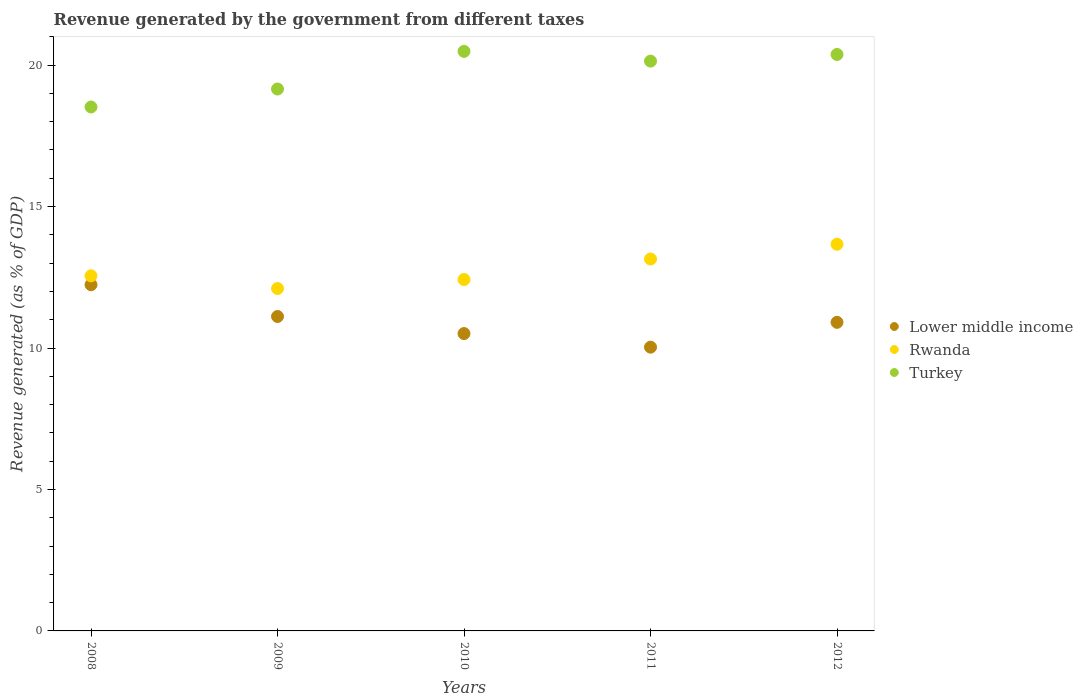How many different coloured dotlines are there?
Your answer should be compact. 3. Is the number of dotlines equal to the number of legend labels?
Offer a terse response. Yes. What is the revenue generated by the government in Rwanda in 2012?
Keep it short and to the point. 13.67. Across all years, what is the maximum revenue generated by the government in Rwanda?
Make the answer very short. 13.67. Across all years, what is the minimum revenue generated by the government in Lower middle income?
Provide a short and direct response. 10.03. What is the total revenue generated by the government in Rwanda in the graph?
Your response must be concise. 63.89. What is the difference between the revenue generated by the government in Rwanda in 2009 and that in 2010?
Your answer should be very brief. -0.32. What is the difference between the revenue generated by the government in Lower middle income in 2011 and the revenue generated by the government in Rwanda in 2009?
Give a very brief answer. -2.07. What is the average revenue generated by the government in Lower middle income per year?
Offer a very short reply. 10.96. In the year 2008, what is the difference between the revenue generated by the government in Turkey and revenue generated by the government in Rwanda?
Give a very brief answer. 5.97. What is the ratio of the revenue generated by the government in Lower middle income in 2010 to that in 2012?
Your answer should be compact. 0.96. Is the revenue generated by the government in Turkey in 2008 less than that in 2009?
Provide a succinct answer. Yes. What is the difference between the highest and the second highest revenue generated by the government in Rwanda?
Keep it short and to the point. 0.52. What is the difference between the highest and the lowest revenue generated by the government in Turkey?
Offer a very short reply. 1.97. Is the sum of the revenue generated by the government in Rwanda in 2008 and 2011 greater than the maximum revenue generated by the government in Lower middle income across all years?
Your answer should be compact. Yes. Is it the case that in every year, the sum of the revenue generated by the government in Rwanda and revenue generated by the government in Lower middle income  is greater than the revenue generated by the government in Turkey?
Give a very brief answer. Yes. Does the revenue generated by the government in Lower middle income monotonically increase over the years?
Keep it short and to the point. No. Is the revenue generated by the government in Rwanda strictly less than the revenue generated by the government in Turkey over the years?
Provide a succinct answer. Yes. How many years are there in the graph?
Make the answer very short. 5. What is the difference between two consecutive major ticks on the Y-axis?
Your response must be concise. 5. Does the graph contain any zero values?
Make the answer very short. No. Does the graph contain grids?
Make the answer very short. No. Where does the legend appear in the graph?
Offer a very short reply. Center right. How many legend labels are there?
Provide a succinct answer. 3. How are the legend labels stacked?
Your response must be concise. Vertical. What is the title of the graph?
Your response must be concise. Revenue generated by the government from different taxes. What is the label or title of the Y-axis?
Your response must be concise. Revenue generated (as % of GDP). What is the Revenue generated (as % of GDP) of Lower middle income in 2008?
Offer a very short reply. 12.24. What is the Revenue generated (as % of GDP) of Rwanda in 2008?
Make the answer very short. 12.55. What is the Revenue generated (as % of GDP) of Turkey in 2008?
Ensure brevity in your answer.  18.52. What is the Revenue generated (as % of GDP) of Lower middle income in 2009?
Make the answer very short. 11.11. What is the Revenue generated (as % of GDP) of Rwanda in 2009?
Make the answer very short. 12.1. What is the Revenue generated (as % of GDP) in Turkey in 2009?
Your answer should be compact. 19.16. What is the Revenue generated (as % of GDP) in Lower middle income in 2010?
Your answer should be compact. 10.51. What is the Revenue generated (as % of GDP) in Rwanda in 2010?
Your answer should be very brief. 12.42. What is the Revenue generated (as % of GDP) of Turkey in 2010?
Ensure brevity in your answer.  20.49. What is the Revenue generated (as % of GDP) in Lower middle income in 2011?
Your response must be concise. 10.03. What is the Revenue generated (as % of GDP) of Rwanda in 2011?
Your answer should be very brief. 13.15. What is the Revenue generated (as % of GDP) of Turkey in 2011?
Keep it short and to the point. 20.14. What is the Revenue generated (as % of GDP) of Lower middle income in 2012?
Your answer should be compact. 10.91. What is the Revenue generated (as % of GDP) of Rwanda in 2012?
Ensure brevity in your answer.  13.67. What is the Revenue generated (as % of GDP) of Turkey in 2012?
Make the answer very short. 20.38. Across all years, what is the maximum Revenue generated (as % of GDP) in Lower middle income?
Your answer should be compact. 12.24. Across all years, what is the maximum Revenue generated (as % of GDP) of Rwanda?
Provide a short and direct response. 13.67. Across all years, what is the maximum Revenue generated (as % of GDP) in Turkey?
Provide a short and direct response. 20.49. Across all years, what is the minimum Revenue generated (as % of GDP) in Lower middle income?
Your response must be concise. 10.03. Across all years, what is the minimum Revenue generated (as % of GDP) of Rwanda?
Ensure brevity in your answer.  12.1. Across all years, what is the minimum Revenue generated (as % of GDP) in Turkey?
Your answer should be compact. 18.52. What is the total Revenue generated (as % of GDP) of Lower middle income in the graph?
Offer a terse response. 54.8. What is the total Revenue generated (as % of GDP) in Rwanda in the graph?
Your response must be concise. 63.89. What is the total Revenue generated (as % of GDP) in Turkey in the graph?
Ensure brevity in your answer.  98.68. What is the difference between the Revenue generated (as % of GDP) in Lower middle income in 2008 and that in 2009?
Provide a short and direct response. 1.12. What is the difference between the Revenue generated (as % of GDP) in Rwanda in 2008 and that in 2009?
Offer a very short reply. 0.45. What is the difference between the Revenue generated (as % of GDP) of Turkey in 2008 and that in 2009?
Make the answer very short. -0.64. What is the difference between the Revenue generated (as % of GDP) in Lower middle income in 2008 and that in 2010?
Keep it short and to the point. 1.73. What is the difference between the Revenue generated (as % of GDP) in Rwanda in 2008 and that in 2010?
Give a very brief answer. 0.13. What is the difference between the Revenue generated (as % of GDP) in Turkey in 2008 and that in 2010?
Make the answer very short. -1.97. What is the difference between the Revenue generated (as % of GDP) of Lower middle income in 2008 and that in 2011?
Ensure brevity in your answer.  2.21. What is the difference between the Revenue generated (as % of GDP) of Rwanda in 2008 and that in 2011?
Keep it short and to the point. -0.59. What is the difference between the Revenue generated (as % of GDP) of Turkey in 2008 and that in 2011?
Provide a short and direct response. -1.62. What is the difference between the Revenue generated (as % of GDP) in Lower middle income in 2008 and that in 2012?
Offer a terse response. 1.33. What is the difference between the Revenue generated (as % of GDP) of Rwanda in 2008 and that in 2012?
Provide a succinct answer. -1.12. What is the difference between the Revenue generated (as % of GDP) of Turkey in 2008 and that in 2012?
Provide a succinct answer. -1.86. What is the difference between the Revenue generated (as % of GDP) of Lower middle income in 2009 and that in 2010?
Provide a succinct answer. 0.6. What is the difference between the Revenue generated (as % of GDP) of Rwanda in 2009 and that in 2010?
Provide a succinct answer. -0.32. What is the difference between the Revenue generated (as % of GDP) in Turkey in 2009 and that in 2010?
Offer a terse response. -1.33. What is the difference between the Revenue generated (as % of GDP) in Lower middle income in 2009 and that in 2011?
Provide a succinct answer. 1.08. What is the difference between the Revenue generated (as % of GDP) of Rwanda in 2009 and that in 2011?
Your answer should be very brief. -1.04. What is the difference between the Revenue generated (as % of GDP) of Turkey in 2009 and that in 2011?
Give a very brief answer. -0.99. What is the difference between the Revenue generated (as % of GDP) in Lower middle income in 2009 and that in 2012?
Offer a very short reply. 0.21. What is the difference between the Revenue generated (as % of GDP) in Rwanda in 2009 and that in 2012?
Provide a short and direct response. -1.56. What is the difference between the Revenue generated (as % of GDP) in Turkey in 2009 and that in 2012?
Make the answer very short. -1.22. What is the difference between the Revenue generated (as % of GDP) of Lower middle income in 2010 and that in 2011?
Ensure brevity in your answer.  0.48. What is the difference between the Revenue generated (as % of GDP) of Rwanda in 2010 and that in 2011?
Your response must be concise. -0.72. What is the difference between the Revenue generated (as % of GDP) in Turkey in 2010 and that in 2011?
Give a very brief answer. 0.34. What is the difference between the Revenue generated (as % of GDP) in Lower middle income in 2010 and that in 2012?
Ensure brevity in your answer.  -0.4. What is the difference between the Revenue generated (as % of GDP) in Rwanda in 2010 and that in 2012?
Give a very brief answer. -1.25. What is the difference between the Revenue generated (as % of GDP) of Turkey in 2010 and that in 2012?
Give a very brief answer. 0.11. What is the difference between the Revenue generated (as % of GDP) in Lower middle income in 2011 and that in 2012?
Your response must be concise. -0.88. What is the difference between the Revenue generated (as % of GDP) of Rwanda in 2011 and that in 2012?
Make the answer very short. -0.52. What is the difference between the Revenue generated (as % of GDP) in Turkey in 2011 and that in 2012?
Give a very brief answer. -0.24. What is the difference between the Revenue generated (as % of GDP) in Lower middle income in 2008 and the Revenue generated (as % of GDP) in Rwanda in 2009?
Provide a succinct answer. 0.13. What is the difference between the Revenue generated (as % of GDP) of Lower middle income in 2008 and the Revenue generated (as % of GDP) of Turkey in 2009?
Make the answer very short. -6.92. What is the difference between the Revenue generated (as % of GDP) of Rwanda in 2008 and the Revenue generated (as % of GDP) of Turkey in 2009?
Your answer should be very brief. -6.6. What is the difference between the Revenue generated (as % of GDP) of Lower middle income in 2008 and the Revenue generated (as % of GDP) of Rwanda in 2010?
Your response must be concise. -0.18. What is the difference between the Revenue generated (as % of GDP) of Lower middle income in 2008 and the Revenue generated (as % of GDP) of Turkey in 2010?
Your answer should be very brief. -8.25. What is the difference between the Revenue generated (as % of GDP) in Rwanda in 2008 and the Revenue generated (as % of GDP) in Turkey in 2010?
Give a very brief answer. -7.93. What is the difference between the Revenue generated (as % of GDP) of Lower middle income in 2008 and the Revenue generated (as % of GDP) of Rwanda in 2011?
Provide a short and direct response. -0.91. What is the difference between the Revenue generated (as % of GDP) in Lower middle income in 2008 and the Revenue generated (as % of GDP) in Turkey in 2011?
Provide a short and direct response. -7.9. What is the difference between the Revenue generated (as % of GDP) in Rwanda in 2008 and the Revenue generated (as % of GDP) in Turkey in 2011?
Make the answer very short. -7.59. What is the difference between the Revenue generated (as % of GDP) of Lower middle income in 2008 and the Revenue generated (as % of GDP) of Rwanda in 2012?
Make the answer very short. -1.43. What is the difference between the Revenue generated (as % of GDP) in Lower middle income in 2008 and the Revenue generated (as % of GDP) in Turkey in 2012?
Keep it short and to the point. -8.14. What is the difference between the Revenue generated (as % of GDP) of Rwanda in 2008 and the Revenue generated (as % of GDP) of Turkey in 2012?
Give a very brief answer. -7.83. What is the difference between the Revenue generated (as % of GDP) of Lower middle income in 2009 and the Revenue generated (as % of GDP) of Rwanda in 2010?
Your answer should be compact. -1.31. What is the difference between the Revenue generated (as % of GDP) of Lower middle income in 2009 and the Revenue generated (as % of GDP) of Turkey in 2010?
Offer a terse response. -9.37. What is the difference between the Revenue generated (as % of GDP) of Rwanda in 2009 and the Revenue generated (as % of GDP) of Turkey in 2010?
Offer a terse response. -8.38. What is the difference between the Revenue generated (as % of GDP) of Lower middle income in 2009 and the Revenue generated (as % of GDP) of Rwanda in 2011?
Give a very brief answer. -2.03. What is the difference between the Revenue generated (as % of GDP) in Lower middle income in 2009 and the Revenue generated (as % of GDP) in Turkey in 2011?
Give a very brief answer. -9.03. What is the difference between the Revenue generated (as % of GDP) in Rwanda in 2009 and the Revenue generated (as % of GDP) in Turkey in 2011?
Give a very brief answer. -8.04. What is the difference between the Revenue generated (as % of GDP) of Lower middle income in 2009 and the Revenue generated (as % of GDP) of Rwanda in 2012?
Keep it short and to the point. -2.55. What is the difference between the Revenue generated (as % of GDP) in Lower middle income in 2009 and the Revenue generated (as % of GDP) in Turkey in 2012?
Your answer should be compact. -9.26. What is the difference between the Revenue generated (as % of GDP) of Rwanda in 2009 and the Revenue generated (as % of GDP) of Turkey in 2012?
Give a very brief answer. -8.27. What is the difference between the Revenue generated (as % of GDP) of Lower middle income in 2010 and the Revenue generated (as % of GDP) of Rwanda in 2011?
Your answer should be very brief. -2.63. What is the difference between the Revenue generated (as % of GDP) of Lower middle income in 2010 and the Revenue generated (as % of GDP) of Turkey in 2011?
Provide a short and direct response. -9.63. What is the difference between the Revenue generated (as % of GDP) of Rwanda in 2010 and the Revenue generated (as % of GDP) of Turkey in 2011?
Your answer should be very brief. -7.72. What is the difference between the Revenue generated (as % of GDP) of Lower middle income in 2010 and the Revenue generated (as % of GDP) of Rwanda in 2012?
Your answer should be very brief. -3.16. What is the difference between the Revenue generated (as % of GDP) in Lower middle income in 2010 and the Revenue generated (as % of GDP) in Turkey in 2012?
Offer a very short reply. -9.87. What is the difference between the Revenue generated (as % of GDP) in Rwanda in 2010 and the Revenue generated (as % of GDP) in Turkey in 2012?
Provide a succinct answer. -7.96. What is the difference between the Revenue generated (as % of GDP) of Lower middle income in 2011 and the Revenue generated (as % of GDP) of Rwanda in 2012?
Offer a very short reply. -3.64. What is the difference between the Revenue generated (as % of GDP) of Lower middle income in 2011 and the Revenue generated (as % of GDP) of Turkey in 2012?
Your response must be concise. -10.35. What is the difference between the Revenue generated (as % of GDP) in Rwanda in 2011 and the Revenue generated (as % of GDP) in Turkey in 2012?
Offer a very short reply. -7.23. What is the average Revenue generated (as % of GDP) of Lower middle income per year?
Ensure brevity in your answer.  10.96. What is the average Revenue generated (as % of GDP) of Rwanda per year?
Ensure brevity in your answer.  12.78. What is the average Revenue generated (as % of GDP) in Turkey per year?
Provide a succinct answer. 19.74. In the year 2008, what is the difference between the Revenue generated (as % of GDP) in Lower middle income and Revenue generated (as % of GDP) in Rwanda?
Your answer should be compact. -0.32. In the year 2008, what is the difference between the Revenue generated (as % of GDP) of Lower middle income and Revenue generated (as % of GDP) of Turkey?
Provide a short and direct response. -6.28. In the year 2008, what is the difference between the Revenue generated (as % of GDP) of Rwanda and Revenue generated (as % of GDP) of Turkey?
Ensure brevity in your answer.  -5.97. In the year 2009, what is the difference between the Revenue generated (as % of GDP) in Lower middle income and Revenue generated (as % of GDP) in Rwanda?
Your answer should be compact. -0.99. In the year 2009, what is the difference between the Revenue generated (as % of GDP) of Lower middle income and Revenue generated (as % of GDP) of Turkey?
Offer a terse response. -8.04. In the year 2009, what is the difference between the Revenue generated (as % of GDP) of Rwanda and Revenue generated (as % of GDP) of Turkey?
Keep it short and to the point. -7.05. In the year 2010, what is the difference between the Revenue generated (as % of GDP) in Lower middle income and Revenue generated (as % of GDP) in Rwanda?
Offer a very short reply. -1.91. In the year 2010, what is the difference between the Revenue generated (as % of GDP) of Lower middle income and Revenue generated (as % of GDP) of Turkey?
Your response must be concise. -9.98. In the year 2010, what is the difference between the Revenue generated (as % of GDP) of Rwanda and Revenue generated (as % of GDP) of Turkey?
Provide a succinct answer. -8.06. In the year 2011, what is the difference between the Revenue generated (as % of GDP) in Lower middle income and Revenue generated (as % of GDP) in Rwanda?
Provide a short and direct response. -3.12. In the year 2011, what is the difference between the Revenue generated (as % of GDP) of Lower middle income and Revenue generated (as % of GDP) of Turkey?
Your answer should be compact. -10.11. In the year 2011, what is the difference between the Revenue generated (as % of GDP) of Rwanda and Revenue generated (as % of GDP) of Turkey?
Offer a terse response. -7. In the year 2012, what is the difference between the Revenue generated (as % of GDP) in Lower middle income and Revenue generated (as % of GDP) in Rwanda?
Offer a very short reply. -2.76. In the year 2012, what is the difference between the Revenue generated (as % of GDP) of Lower middle income and Revenue generated (as % of GDP) of Turkey?
Provide a succinct answer. -9.47. In the year 2012, what is the difference between the Revenue generated (as % of GDP) in Rwanda and Revenue generated (as % of GDP) in Turkey?
Provide a succinct answer. -6.71. What is the ratio of the Revenue generated (as % of GDP) in Lower middle income in 2008 to that in 2009?
Ensure brevity in your answer.  1.1. What is the ratio of the Revenue generated (as % of GDP) of Rwanda in 2008 to that in 2009?
Offer a very short reply. 1.04. What is the ratio of the Revenue generated (as % of GDP) of Turkey in 2008 to that in 2009?
Provide a short and direct response. 0.97. What is the ratio of the Revenue generated (as % of GDP) of Lower middle income in 2008 to that in 2010?
Your answer should be very brief. 1.16. What is the ratio of the Revenue generated (as % of GDP) of Rwanda in 2008 to that in 2010?
Ensure brevity in your answer.  1.01. What is the ratio of the Revenue generated (as % of GDP) in Turkey in 2008 to that in 2010?
Offer a terse response. 0.9. What is the ratio of the Revenue generated (as % of GDP) of Lower middle income in 2008 to that in 2011?
Offer a terse response. 1.22. What is the ratio of the Revenue generated (as % of GDP) of Rwanda in 2008 to that in 2011?
Your response must be concise. 0.95. What is the ratio of the Revenue generated (as % of GDP) in Turkey in 2008 to that in 2011?
Ensure brevity in your answer.  0.92. What is the ratio of the Revenue generated (as % of GDP) of Lower middle income in 2008 to that in 2012?
Give a very brief answer. 1.12. What is the ratio of the Revenue generated (as % of GDP) in Rwanda in 2008 to that in 2012?
Keep it short and to the point. 0.92. What is the ratio of the Revenue generated (as % of GDP) in Turkey in 2008 to that in 2012?
Offer a terse response. 0.91. What is the ratio of the Revenue generated (as % of GDP) of Lower middle income in 2009 to that in 2010?
Your answer should be very brief. 1.06. What is the ratio of the Revenue generated (as % of GDP) in Rwanda in 2009 to that in 2010?
Offer a terse response. 0.97. What is the ratio of the Revenue generated (as % of GDP) in Turkey in 2009 to that in 2010?
Your answer should be very brief. 0.94. What is the ratio of the Revenue generated (as % of GDP) in Lower middle income in 2009 to that in 2011?
Keep it short and to the point. 1.11. What is the ratio of the Revenue generated (as % of GDP) of Rwanda in 2009 to that in 2011?
Your answer should be compact. 0.92. What is the ratio of the Revenue generated (as % of GDP) of Turkey in 2009 to that in 2011?
Your response must be concise. 0.95. What is the ratio of the Revenue generated (as % of GDP) of Lower middle income in 2009 to that in 2012?
Offer a very short reply. 1.02. What is the ratio of the Revenue generated (as % of GDP) in Rwanda in 2009 to that in 2012?
Your response must be concise. 0.89. What is the ratio of the Revenue generated (as % of GDP) of Turkey in 2009 to that in 2012?
Make the answer very short. 0.94. What is the ratio of the Revenue generated (as % of GDP) in Lower middle income in 2010 to that in 2011?
Give a very brief answer. 1.05. What is the ratio of the Revenue generated (as % of GDP) in Rwanda in 2010 to that in 2011?
Ensure brevity in your answer.  0.94. What is the ratio of the Revenue generated (as % of GDP) of Turkey in 2010 to that in 2011?
Provide a succinct answer. 1.02. What is the ratio of the Revenue generated (as % of GDP) in Lower middle income in 2010 to that in 2012?
Your response must be concise. 0.96. What is the ratio of the Revenue generated (as % of GDP) of Rwanda in 2010 to that in 2012?
Offer a very short reply. 0.91. What is the ratio of the Revenue generated (as % of GDP) of Turkey in 2010 to that in 2012?
Make the answer very short. 1.01. What is the ratio of the Revenue generated (as % of GDP) in Lower middle income in 2011 to that in 2012?
Your answer should be very brief. 0.92. What is the ratio of the Revenue generated (as % of GDP) in Rwanda in 2011 to that in 2012?
Give a very brief answer. 0.96. What is the ratio of the Revenue generated (as % of GDP) in Turkey in 2011 to that in 2012?
Offer a very short reply. 0.99. What is the difference between the highest and the second highest Revenue generated (as % of GDP) of Lower middle income?
Your response must be concise. 1.12. What is the difference between the highest and the second highest Revenue generated (as % of GDP) in Rwanda?
Make the answer very short. 0.52. What is the difference between the highest and the second highest Revenue generated (as % of GDP) in Turkey?
Your answer should be compact. 0.11. What is the difference between the highest and the lowest Revenue generated (as % of GDP) of Lower middle income?
Your answer should be very brief. 2.21. What is the difference between the highest and the lowest Revenue generated (as % of GDP) in Rwanda?
Your response must be concise. 1.56. What is the difference between the highest and the lowest Revenue generated (as % of GDP) of Turkey?
Keep it short and to the point. 1.97. 